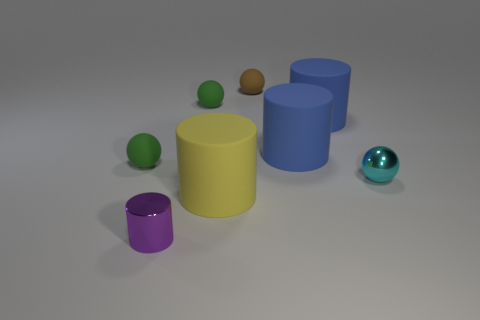Add 1 large gray objects. How many objects exist? 9 Subtract all rubber cylinders. Subtract all small rubber spheres. How many objects are left? 2 Add 5 small purple shiny objects. How many small purple shiny objects are left? 6 Add 4 big purple cubes. How many big purple cubes exist? 4 Subtract 0 gray spheres. How many objects are left? 8 